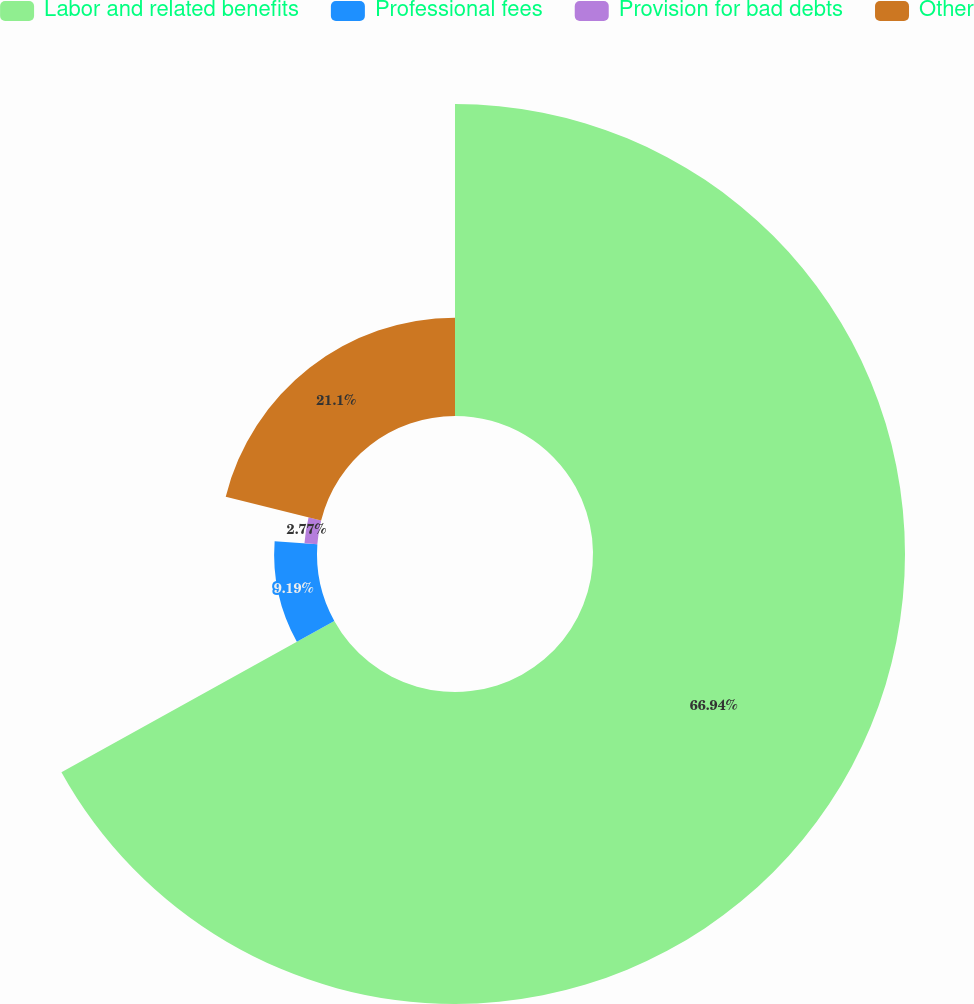Convert chart. <chart><loc_0><loc_0><loc_500><loc_500><pie_chart><fcel>Labor and related benefits<fcel>Professional fees<fcel>Provision for bad debts<fcel>Other<nl><fcel>66.95%<fcel>9.19%<fcel>2.77%<fcel>21.1%<nl></chart> 